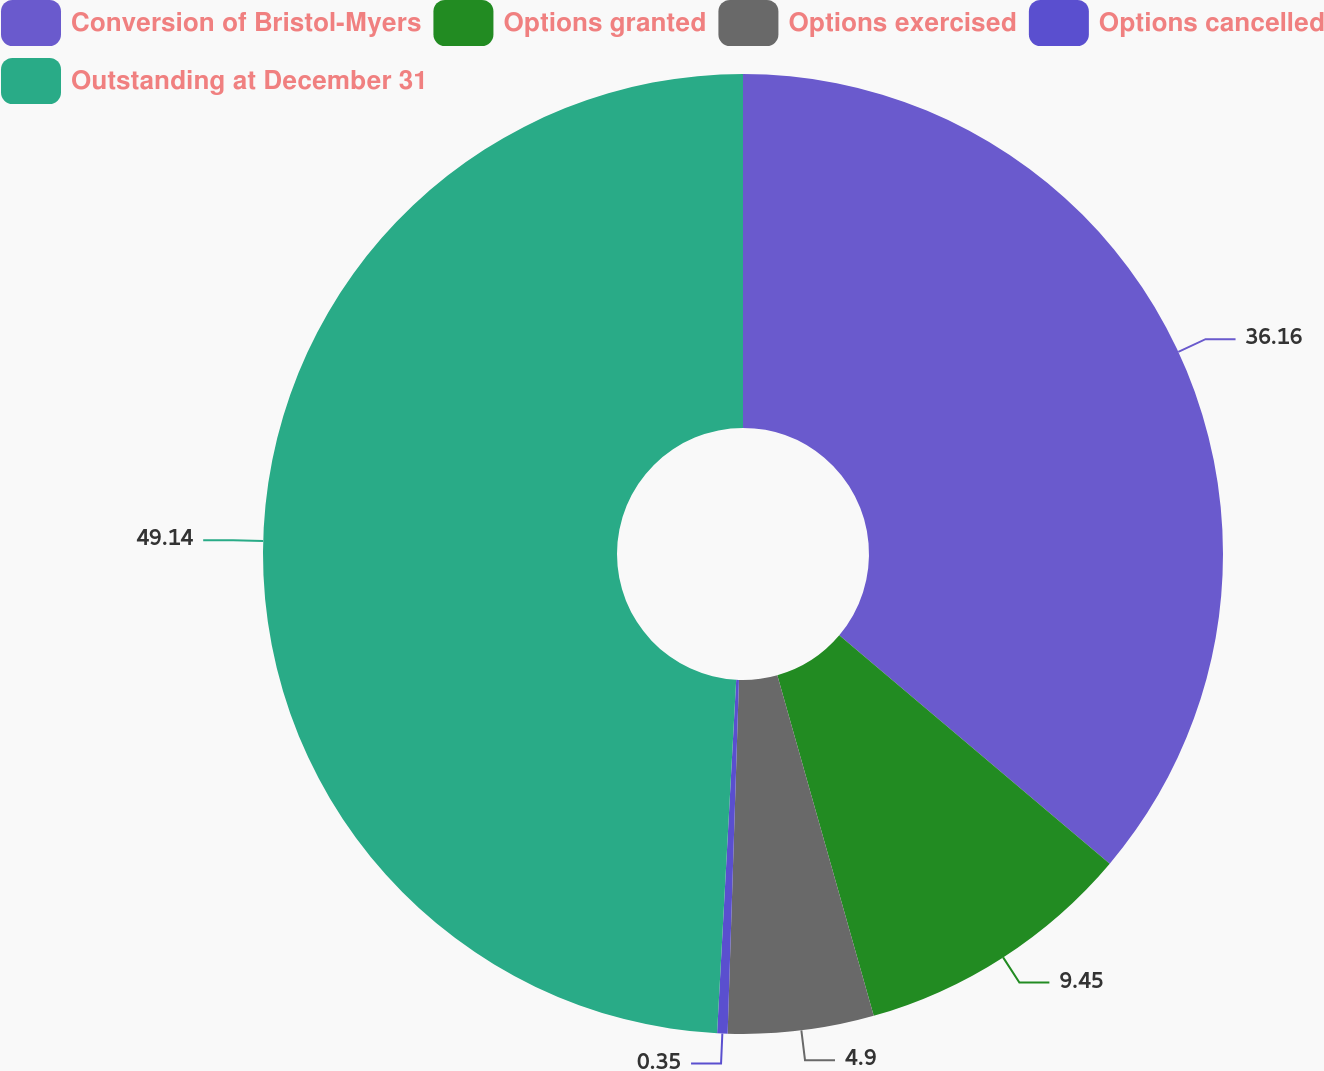Convert chart to OTSL. <chart><loc_0><loc_0><loc_500><loc_500><pie_chart><fcel>Conversion of Bristol-Myers<fcel>Options granted<fcel>Options exercised<fcel>Options cancelled<fcel>Outstanding at December 31<nl><fcel>36.16%<fcel>9.45%<fcel>4.9%<fcel>0.35%<fcel>49.14%<nl></chart> 